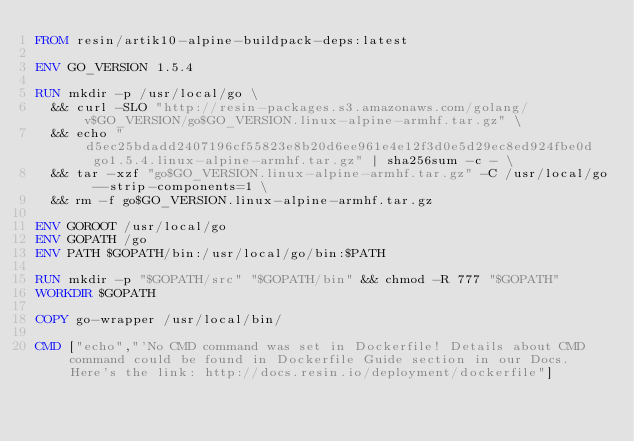<code> <loc_0><loc_0><loc_500><loc_500><_Dockerfile_>FROM resin/artik10-alpine-buildpack-deps:latest

ENV GO_VERSION 1.5.4

RUN mkdir -p /usr/local/go \
	&& curl -SLO "http://resin-packages.s3.amazonaws.com/golang/v$GO_VERSION/go$GO_VERSION.linux-alpine-armhf.tar.gz" \
	&& echo "d5ec25bdadd2407196cf55823e8b20d6ee961e4e12f3d0e5d29ec8ed924fbe0d  go1.5.4.linux-alpine-armhf.tar.gz" | sha256sum -c - \
	&& tar -xzf "go$GO_VERSION.linux-alpine-armhf.tar.gz" -C /usr/local/go --strip-components=1 \
	&& rm -f go$GO_VERSION.linux-alpine-armhf.tar.gz

ENV GOROOT /usr/local/go
ENV GOPATH /go
ENV PATH $GOPATH/bin:/usr/local/go/bin:$PATH

RUN mkdir -p "$GOPATH/src" "$GOPATH/bin" && chmod -R 777 "$GOPATH"
WORKDIR $GOPATH

COPY go-wrapper /usr/local/bin/

CMD ["echo","'No CMD command was set in Dockerfile! Details about CMD command could be found in Dockerfile Guide section in our Docs. Here's the link: http://docs.resin.io/deployment/dockerfile"]
</code> 